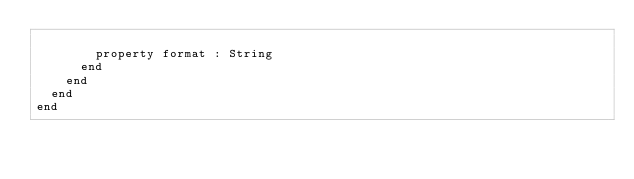<code> <loc_0><loc_0><loc_500><loc_500><_Crystal_>
        property format : String
      end
    end
  end
end
</code> 